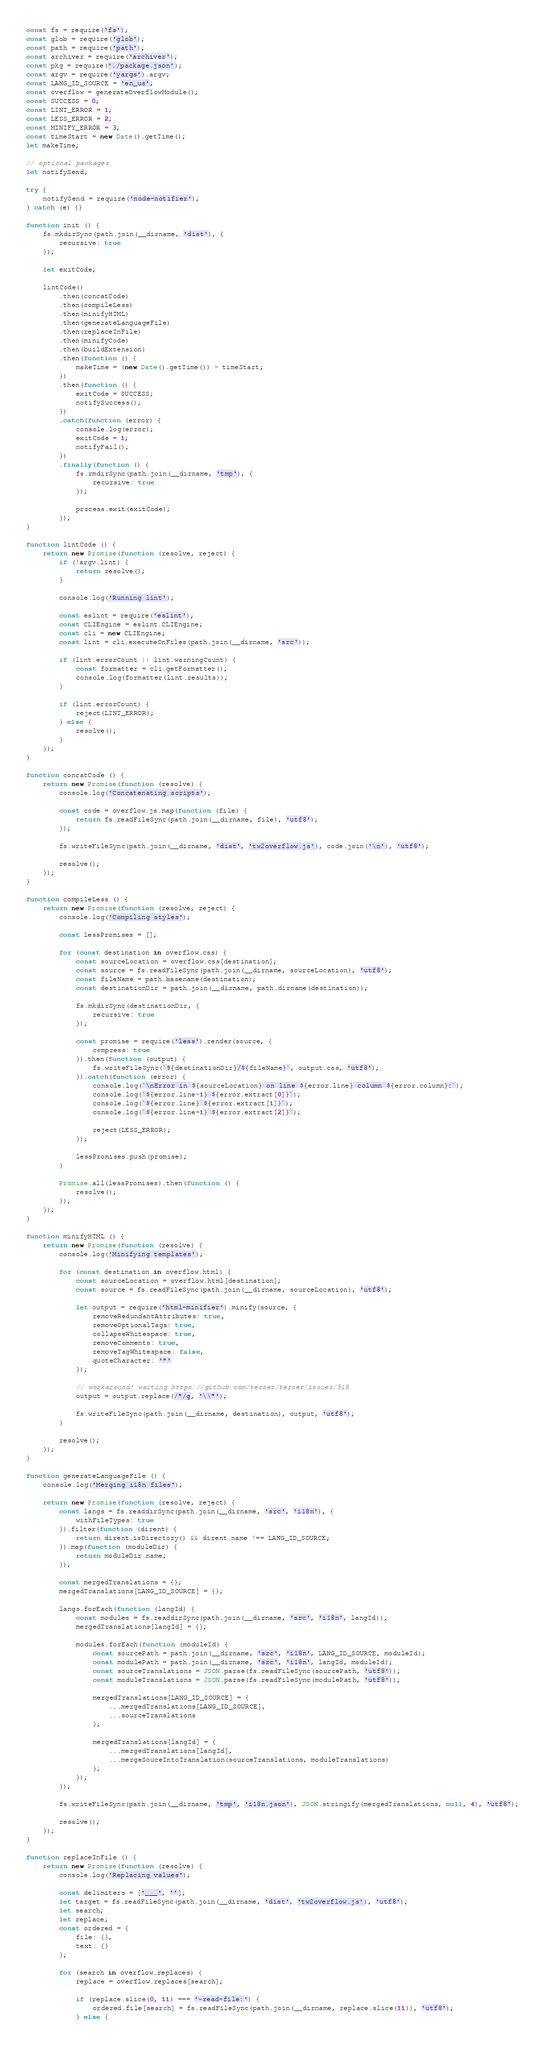<code> <loc_0><loc_0><loc_500><loc_500><_JavaScript_>const fs = require('fs');
const glob = require('glob');
const path = require('path');
const archiver = require('archiver');
const pkg = require('./package.json');
const argv = require('yargs').argv;
const LANG_ID_SOURCE = 'en_us';
const overflow = generateOverflowModule();
const SUCCESS = 0;
const LINT_ERROR = 1;
const LESS_ERROR = 2;
const MINIFY_ERROR = 3;
const timeStart = new Date().getTime();
let makeTime;

// optional packages
let notifySend;

try {
    notifySend = require('node-notifier');
} catch (e) {}

function init () {
    fs.mkdirSync(path.join(__dirname, 'dist'), {
        recursive: true
    });

    let exitCode;

    lintCode()
        .then(concatCode)
        .then(compileLess)
        .then(minifyHTML)
        .then(generateLanguageFile)
        .then(replaceInFile)
        .then(minifyCode)
        .then(buildExtension)
        .then(function () {
            makeTime = (new Date().getTime()) - timeStart;
        })
        .then(function () {
            exitCode = SUCCESS;
            notifySuccess();
        })
        .catch(function (error) {
            console.log(error);
            exitCode = 1;
            notifyFail();
        })
        .finally(function () {
            fs.rmdirSync(path.join(__dirname, 'tmp'), {
                recursive: true
            });

            process.exit(exitCode);
        });
}

function lintCode () {
    return new Promise(function (resolve, reject) {
        if (!argv.lint) {
            return resolve();
        }

        console.log('Running lint');

        const eslint = require('eslint');
        const CLIEngine = eslint.CLIEngine;
        const cli = new CLIEngine;
        const lint = cli.executeOnFiles(path.join(__dirname, 'src'));

        if (lint.errorCount || lint.warningCount) {
            const formatter = cli.getFormatter();
            console.log(formatter(lint.results));
        }

        if (lint.errorCount) {
            reject(LINT_ERROR);
        } else {
            resolve();
        }
    });
}

function concatCode () {
    return new Promise(function (resolve) {
        console.log('Concatenating scripts');

        const code = overflow.js.map(function (file) {
            return fs.readFileSync(path.join(__dirname, file), 'utf8');
        });

        fs.writeFileSync(path.join(__dirname, 'dist', 'tw2overflow.js'), code.join('\n'), 'utf8');

        resolve();
    });
}

function compileLess () {
    return new Promise(function (resolve, reject) {
        console.log('Compiling styles');

        const lessPromises = [];

        for (const destination in overflow.css) {
            const sourceLocation = overflow.css[destination];
            const source = fs.readFileSync(path.join(__dirname, sourceLocation), 'utf8');
            const fileName = path.basename(destination);
            const destinationDir = path.join(__dirname, path.dirname(destination));

            fs.mkdirSync(destinationDir, {
                recursive: true
            });

            const promise = require('less').render(source, {
                compress: true
            }).then(function (output) {
                fs.writeFileSync(`${destinationDir}/${fileName}`, output.css, 'utf8');
            }).catch(function (error) {
                console.log(`\nError in ${sourceLocation} on line ${error.line} column ${error.column}:`);
                console.log(`${error.line-1} ${error.extract[0]}`);
                console.log(`${error.line} ${error.extract[1]}`);
                console.log(`${error.line+1} ${error.extract[2]}`);

                reject(LESS_ERROR);
            });

            lessPromises.push(promise);
        }

        Promise.all(lessPromises).then(function () {
            resolve();
        });
    });
}

function minifyHTML () {
    return new Promise(function (resolve) {
        console.log('Minifying templates');

        for (const destination in overflow.html) {
            const sourceLocation = overflow.html[destination];
            const source = fs.readFileSync(path.join(__dirname, sourceLocation), 'utf8');

            let output = require('html-minifier').minify(source, {
                removeRedundantAttributes: true,
                removeOptionalTags: true,
                collapseWhitespace: true,
                removeComments: true,
                removeTagWhitespace: false,
                quoteCharacter: '"'
            });

            // workaround! waiting https://github.com/terser/terser/issues/518
            output = output.replace(/"/g, '\\"');

            fs.writeFileSync(path.join(__dirname, destination), output, 'utf8');
        }

        resolve();
    });
}

function generateLanguageFile () {
    console.log('Merging i18n files');

    return new Promise(function (resolve, reject) {
        const langs = fs.readdirSync(path.join(__dirname, 'src', 'i18n'), {
            withFileTypes: true
        }).filter(function (dirent) {
            return dirent.isDirectory() && dirent.name !== LANG_ID_SOURCE;
        }).map(function (moduleDir) {
            return moduleDir.name;
        });

        const mergedTranslations = {};
        mergedTranslations[LANG_ID_SOURCE] = {};

        langs.forEach(function (langId) {
            const modules = fs.readdirSync(path.join(__dirname, 'src', 'i18n', langId));
            mergedTranslations[langId] = {};

            modules.forEach(function (moduleId) {
                const sourcePath = path.join(__dirname, 'src', 'i18n', LANG_ID_SOURCE, moduleId);
                const modulePath = path.join(__dirname, 'src', 'i18n', langId, moduleId);
                const sourceTranslations = JSON.parse(fs.readFileSync(sourcePath, 'utf8'));
                const moduleTranslations = JSON.parse(fs.readFileSync(modulePath, 'utf8'));

                mergedTranslations[LANG_ID_SOURCE] = {
                    ...mergedTranslations[LANG_ID_SOURCE],
                    ...sourceTranslations
                };

                mergedTranslations[langId] = {
                    ...mergedTranslations[langId],
                    ...mergeSouceIntoTranslation(sourceTranslations, moduleTranslations)
                };
            });
        });

        fs.writeFileSync(path.join(__dirname, 'tmp', 'i18n.json'), JSON.stringify(mergedTranslations, null, 4), 'utf8');

        resolve();
    });
}

function replaceInFile () {
    return new Promise(function (resolve) {
        console.log('Replacing values');

        const delimiters = ['___', ''];
        let target = fs.readFileSync(path.join(__dirname, 'dist', 'tw2overflow.js'), 'utf8');
        let search;
        let replace;
        const ordered = {
            file: {},
            text: {}
        };

        for (search in overflow.replaces) {
            replace = overflow.replaces[search];

            if (replace.slice(0, 11) === '~read-file:') {
                ordered.file[search] = fs.readFileSync(path.join(__dirname, replace.slice(11)), 'utf8');
            } else {</code> 